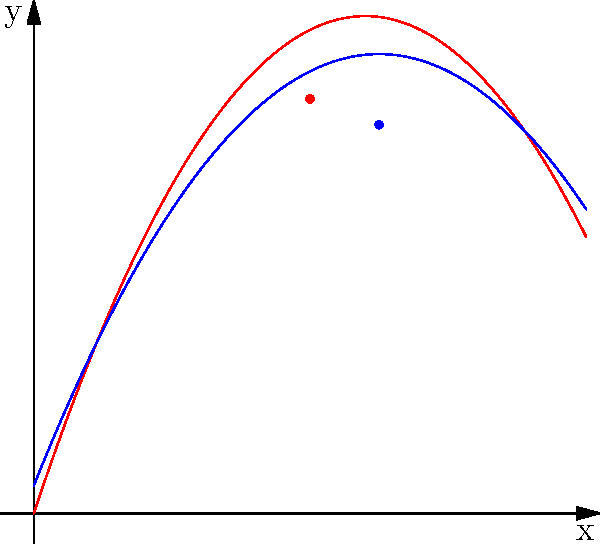The trajectories of Michael Jordan's and Scottie Pippen's jump shots are represented by two parabolas. Jordan's shot follows the equation $y = -0.25x^2 + 3x$, while Pippen's shot follows $y = -0.2x^2 + 2.5x + 0.5$. At what point do these two legendary Bulls players' shots intersect? To find the intersection point of the two parabolas, we need to solve the equation:

$$-0.25x^2 + 3x = -0.2x^2 + 2.5x + 0.5$$

1) First, let's rearrange the equation to standard form:
   $$-0.25x^2 + 3x = -0.2x^2 + 2.5x + 0.5$$
   $$-0.05x^2 + 0.5x - 0.5 = 0$$

2) Multiply all terms by -20 to eliminate fractions:
   $$x^2 - 10x + 10 = 0$$

3) This is a quadratic equation. We can solve it using the quadratic formula:
   $$x = \frac{-b \pm \sqrt{b^2 - 4ac}}{2a}$$
   where $a=1$, $b=-10$, and $c=10$

4) Plugging in these values:
   $$x = \frac{10 \pm \sqrt{100 - 40}}{2} = \frac{10 \pm \sqrt{60}}{2}$$

5) Simplifying:
   $$x = 5 \pm \sqrt{15}$$

6) The positive solution is approximately 8.87, which is within our domain.

7) To find the y-coordinate, we can plug this x-value into either of the original equations. Let's use Jordan's:
   $$y = -0.25(8.87)^2 + 3(8.87) \approx 7.96$$

Therefore, the intersection point is approximately (8.87, 7.96).
Answer: (8.87, 7.96) 